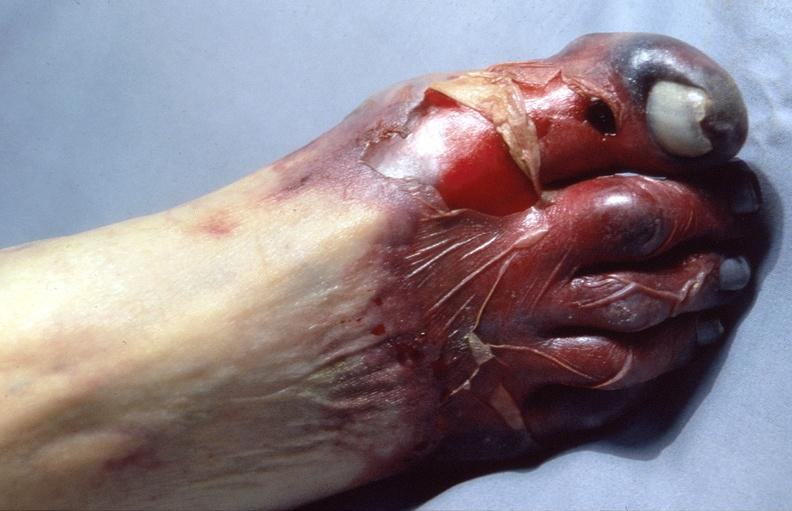where is this?
Answer the question using a single word or phrase. Skin 